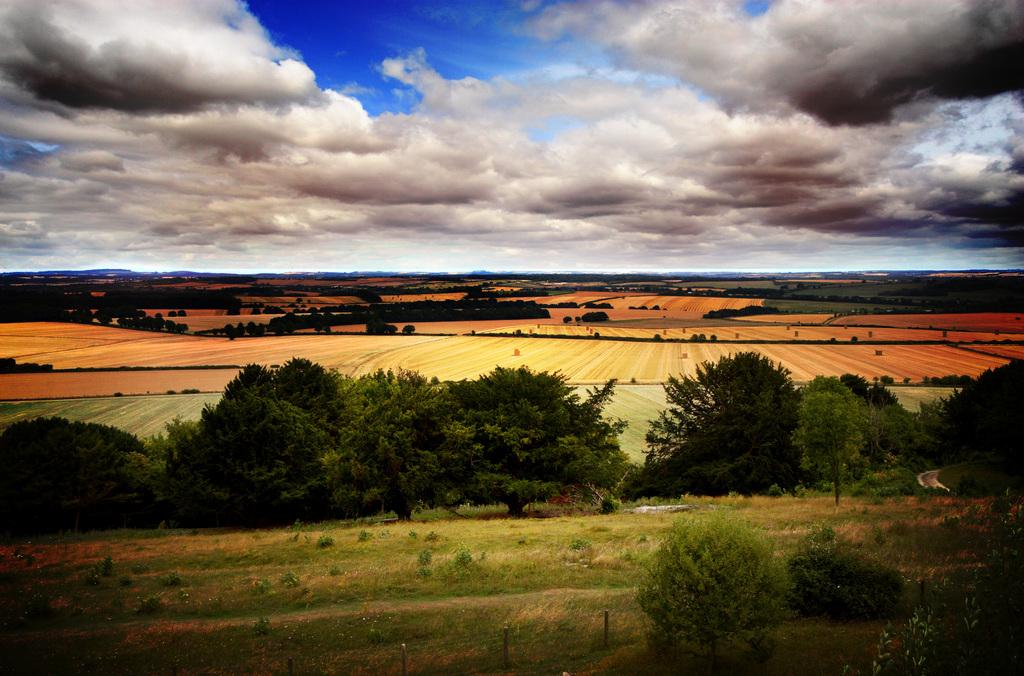What type of vegetation is present in the image? There are trees in the image. What type of ground surface can be seen in the image? There is grass and sand in the image. What is visible in the background of the image? The sky is visible in the image. What can be observed in the sky? There are clouds in the sky. What type of screw can be seen in the image? There is no screw present in the image. What mode of transport is visible in the image? There is no mode of transport visible in the image. 